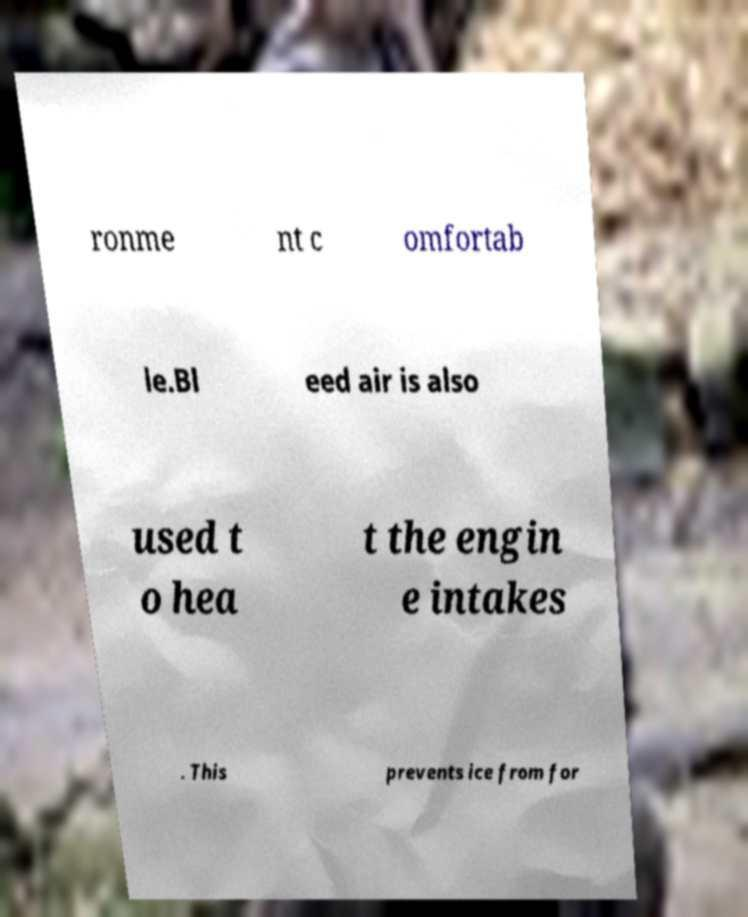Please read and relay the text visible in this image. What does it say? ronme nt c omfortab le.Bl eed air is also used t o hea t the engin e intakes . This prevents ice from for 